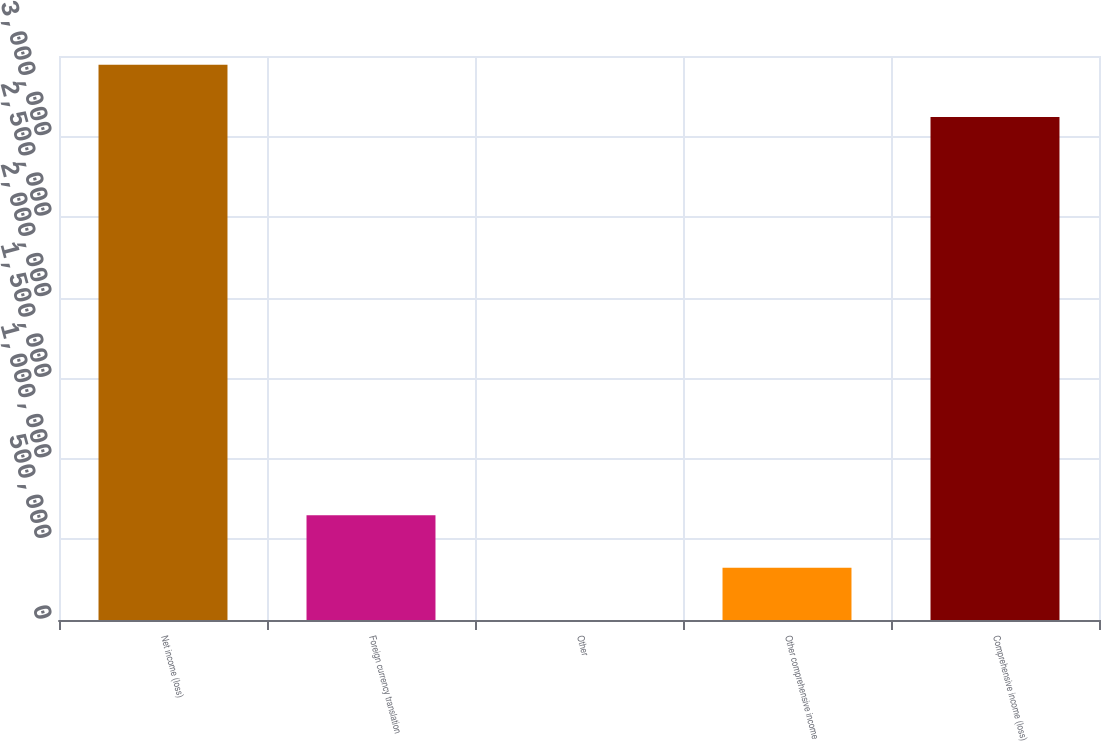<chart> <loc_0><loc_0><loc_500><loc_500><bar_chart><fcel>Net income (loss)<fcel>Foreign currency translation<fcel>Other<fcel>Other comprehensive income<fcel>Comprehensive income (loss)<nl><fcel>3.44557e+06<fcel>649349<fcel>37<fcel>324693<fcel>3.12092e+06<nl></chart> 